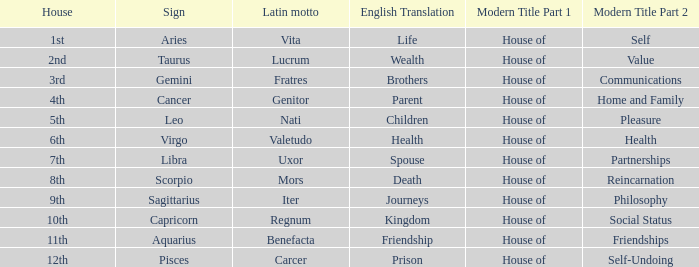Which modern house title translates to prison? House of Self-Undoing. 